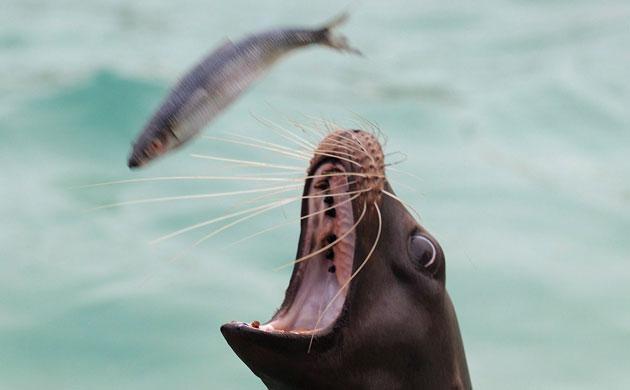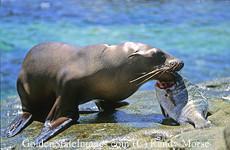The first image is the image on the left, the second image is the image on the right. For the images shown, is this caption "The right image shows a seal with a fish held in its mouth." true? Answer yes or no. Yes. The first image is the image on the left, the second image is the image on the right. Examine the images to the left and right. Is the description "At least one seal is eating a fish." accurate? Answer yes or no. Yes. 